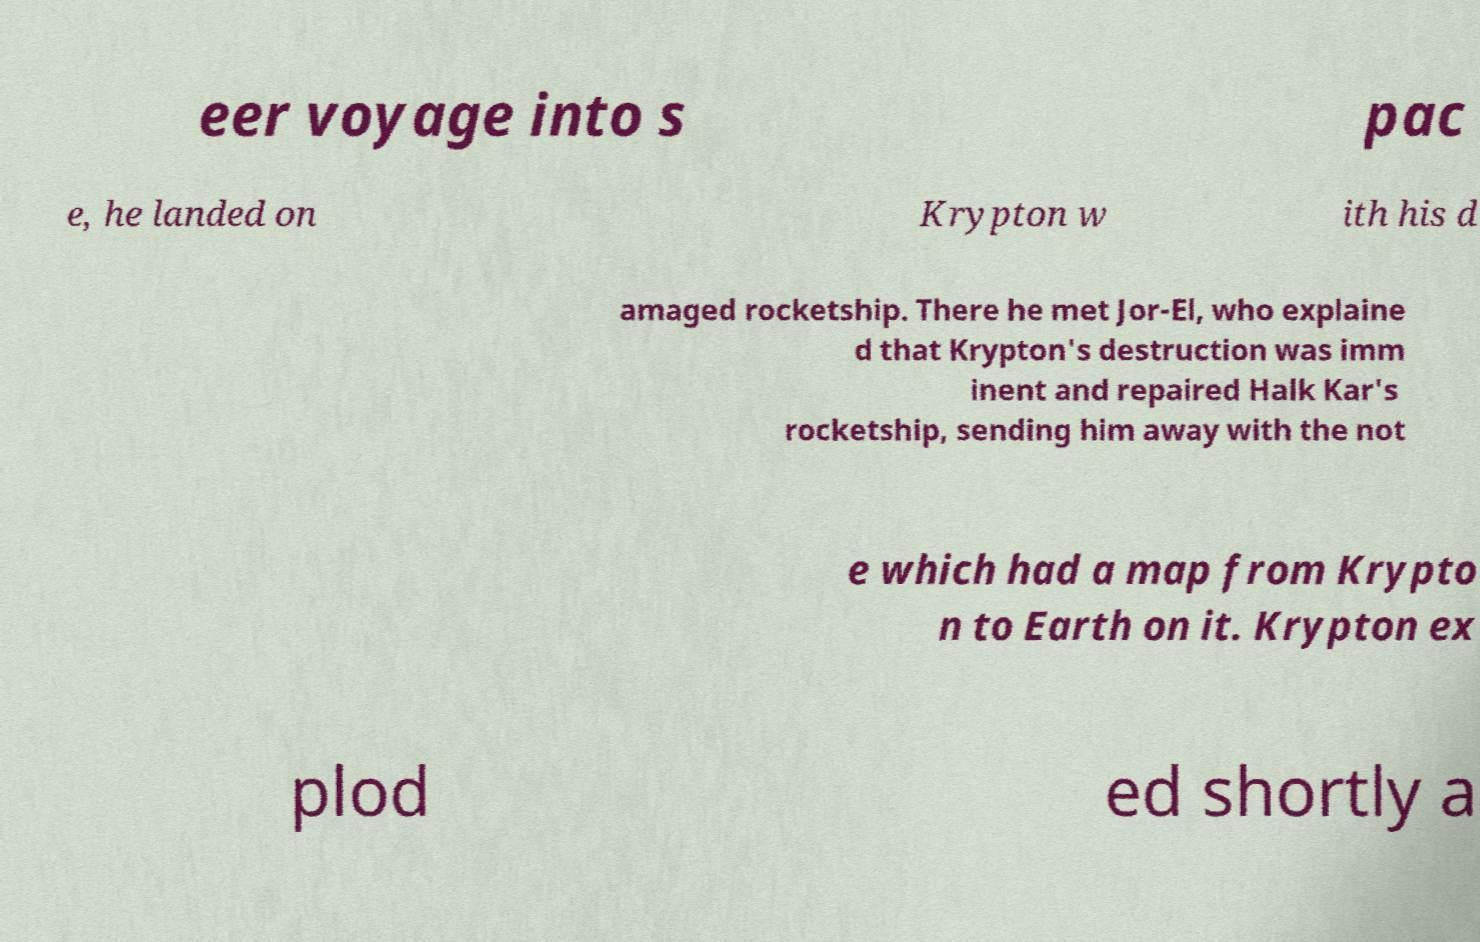Please identify and transcribe the text found in this image. eer voyage into s pac e, he landed on Krypton w ith his d amaged rocketship. There he met Jor-El, who explaine d that Krypton's destruction was imm inent and repaired Halk Kar's rocketship, sending him away with the not e which had a map from Krypto n to Earth on it. Krypton ex plod ed shortly a 